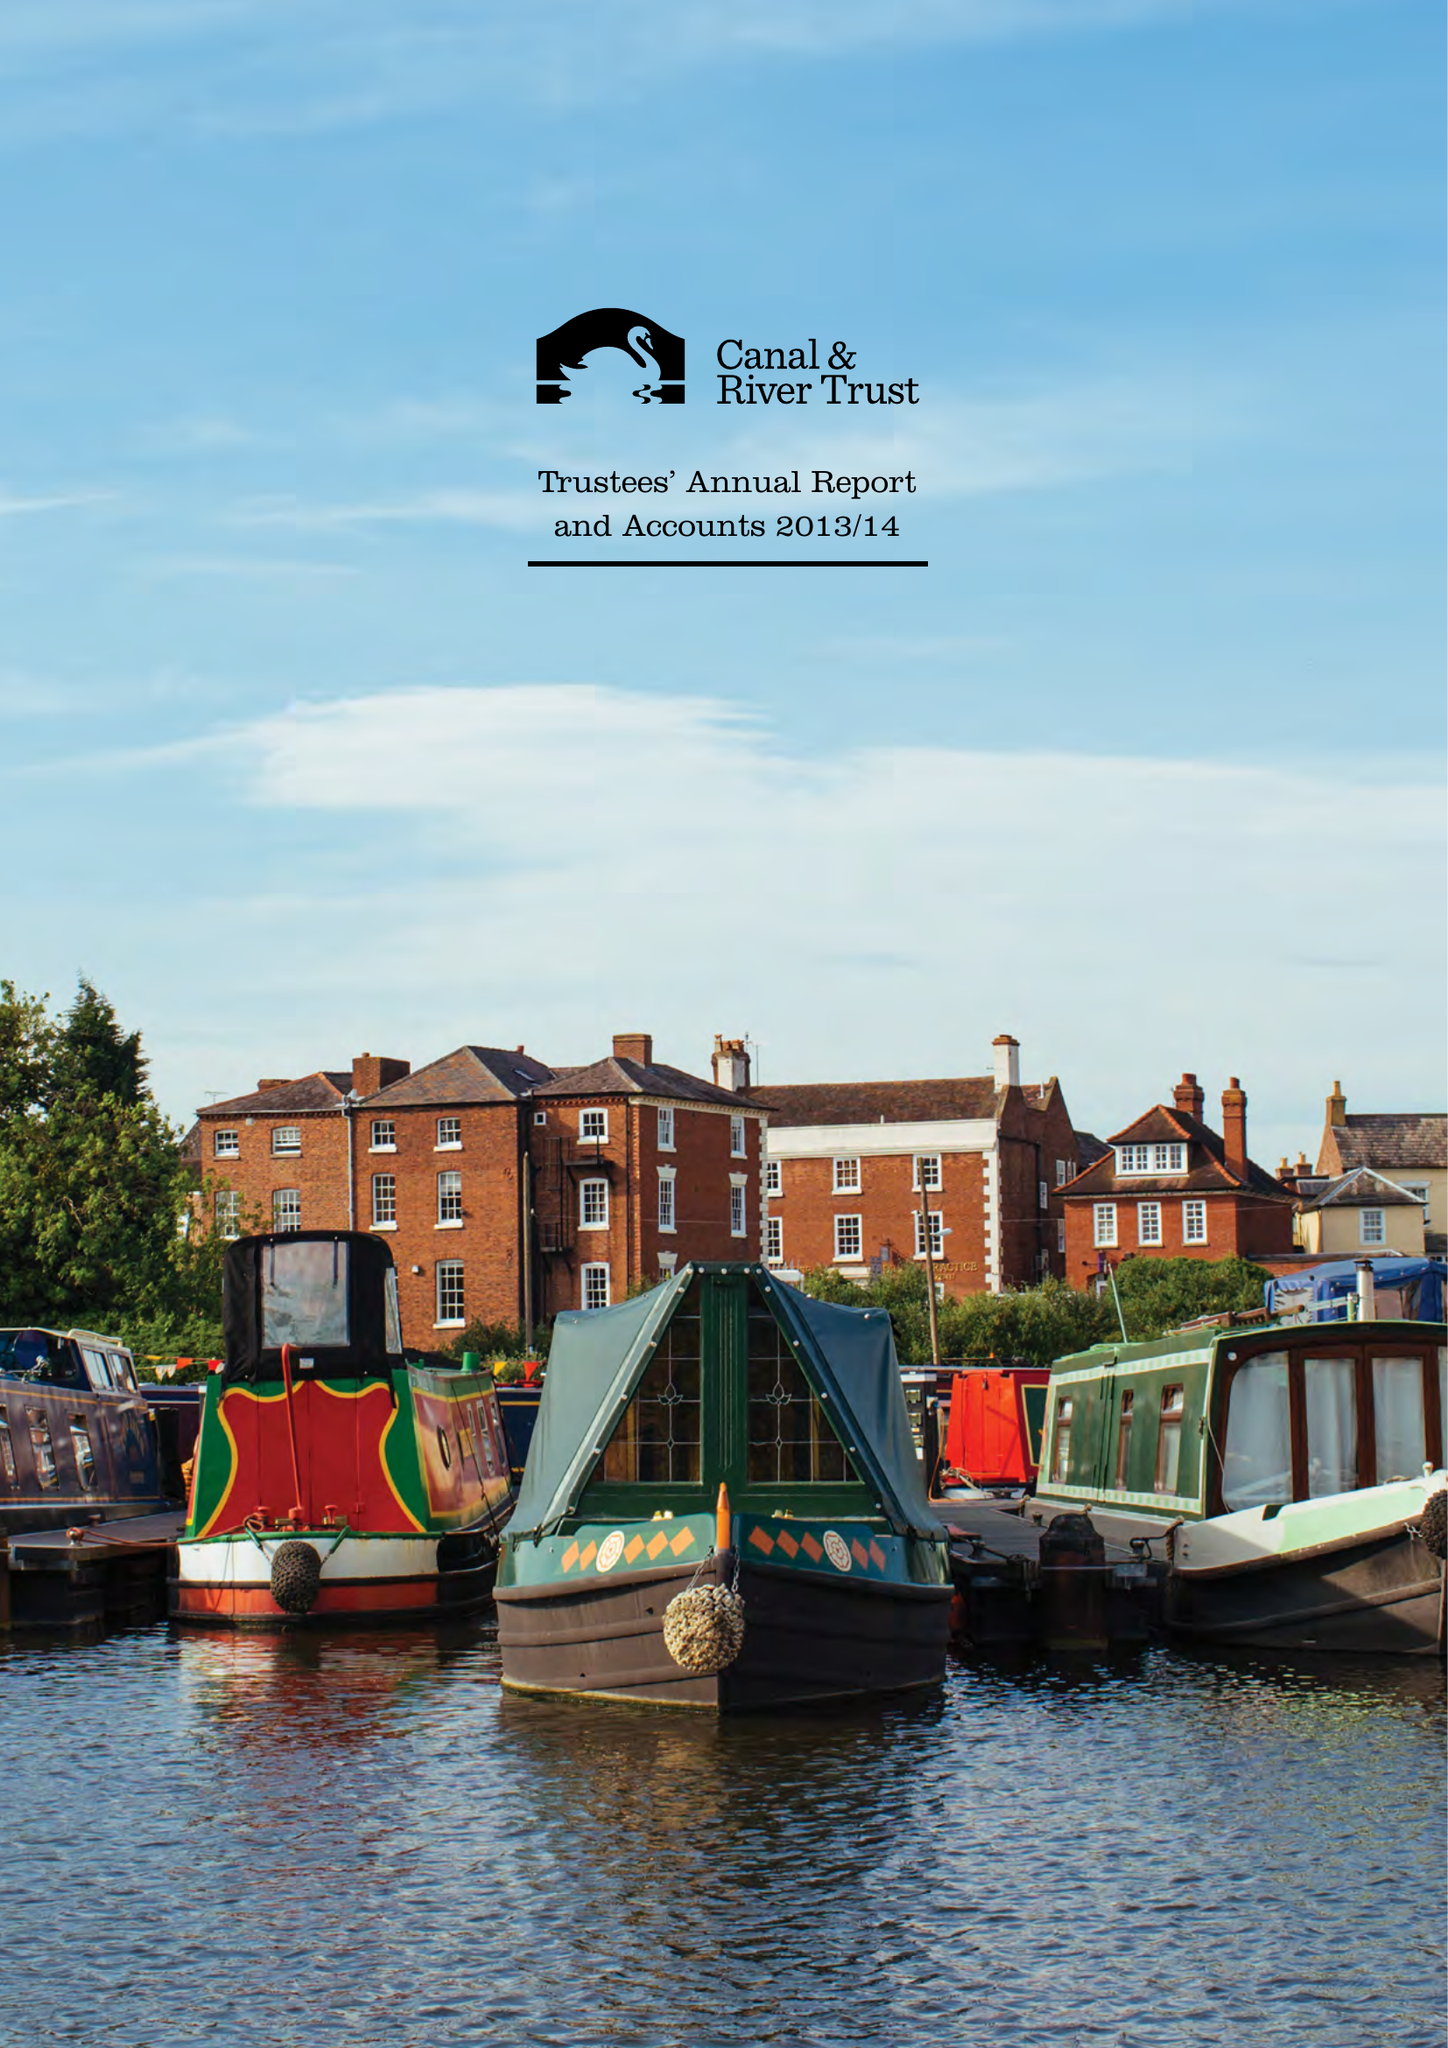What is the value for the charity_number?
Answer the question using a single word or phrase. 1146792 